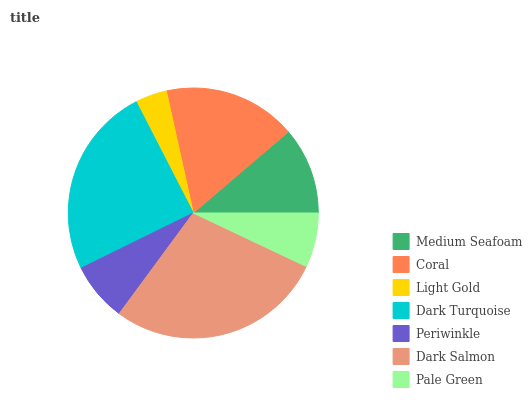Is Light Gold the minimum?
Answer yes or no. Yes. Is Dark Salmon the maximum?
Answer yes or no. Yes. Is Coral the minimum?
Answer yes or no. No. Is Coral the maximum?
Answer yes or no. No. Is Coral greater than Medium Seafoam?
Answer yes or no. Yes. Is Medium Seafoam less than Coral?
Answer yes or no. Yes. Is Medium Seafoam greater than Coral?
Answer yes or no. No. Is Coral less than Medium Seafoam?
Answer yes or no. No. Is Medium Seafoam the high median?
Answer yes or no. Yes. Is Medium Seafoam the low median?
Answer yes or no. Yes. Is Pale Green the high median?
Answer yes or no. No. Is Light Gold the low median?
Answer yes or no. No. 